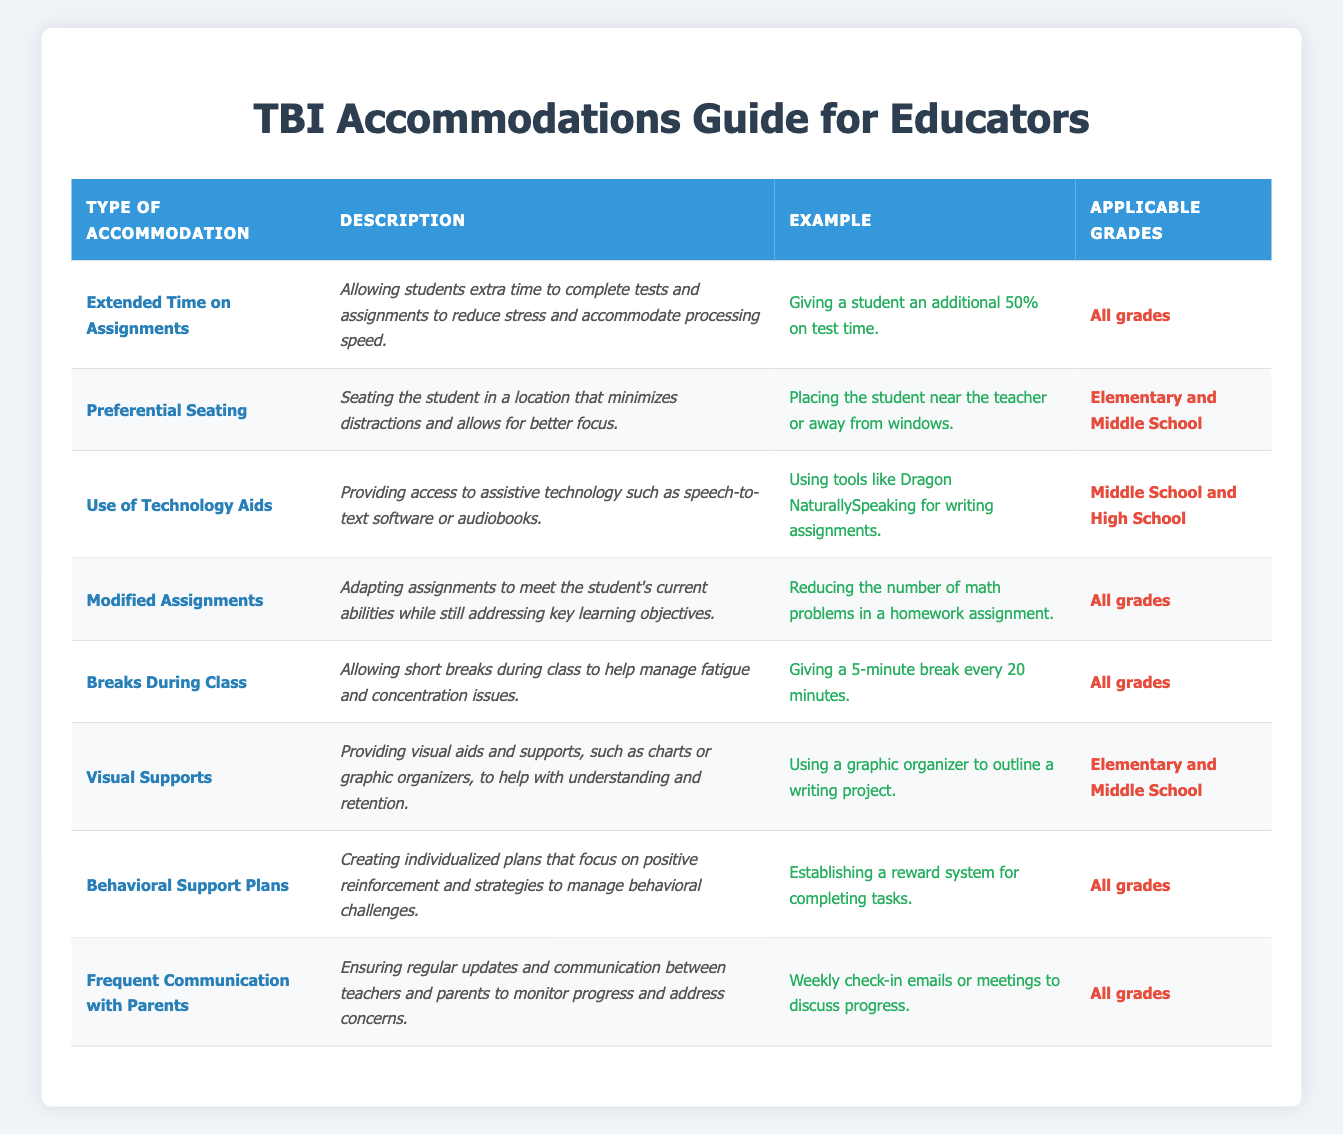What type of accommodation allows students extra time to complete tests? The table lists "Extended Time on Assignments" as the type of accommodation that allows students to have extra time for tests and assignments.
Answer: Extended Time on Assignments Which grades can benefit from the accommodation of Preferential Seating? According to the table, "Preferential Seating" is applicable to "Elementary and Middle School" grades.
Answer: Elementary and Middle School Are Behavioral Support Plans available for all grades? The table indicates that "Behavioral Support Plans" are designed for all grades, confirming that this accommodation is inclusive.
Answer: Yes How many accommodations are specifically listed for Elementary and Middle School? The table shows accommodations specifically listed for "Elementary and Middle School" are "Preferential Seating," "Visual Supports," and "Breaks During Class," totaling 3 accommodations.
Answer: 3 What is the common feature of accommodations listed for all grades? Reviewing the table, the common feature is that accommodations such as "Extended Time on Assignments," "Modified Assignments," "Breaks During Class," "Behavioral Support Plans," and "Frequent Communication with Parents" are available for all grades.
Answer: 5 accommodations If a student needs technology aids, which grades are applicable? The table clearly specifies that "Use of Technology Aids" is applicable to "Middle School and High School." Therefore, students in these grades can access this support.
Answer: Middle School and High School Which accommodation provides visual aids like charts and graphic organizers? The accommodation specified as providing visual aids is "Visual Supports," as noted in the table, which also explains its purpose to aid understanding and retention.
Answer: Visual Supports What is the average number of accommodations applicable to each type of school level based on the provided data? Counting accommodations: "All grades" has 5, "Elementary and Middle School" has 3, and "Middle School and High School" has 1. Adding these and dividing by the number of unique education levels (3) gives an average of (5 + 3 + 1) / 3 = 3.
Answer: 3 What type of accommodation focuses on consistent communication with parents? The table indicates "Frequent Communication with Parents" as the accommodation that emphasizes consistent and regular updates to monitor student progress.
Answer: Frequent Communication with Parents 